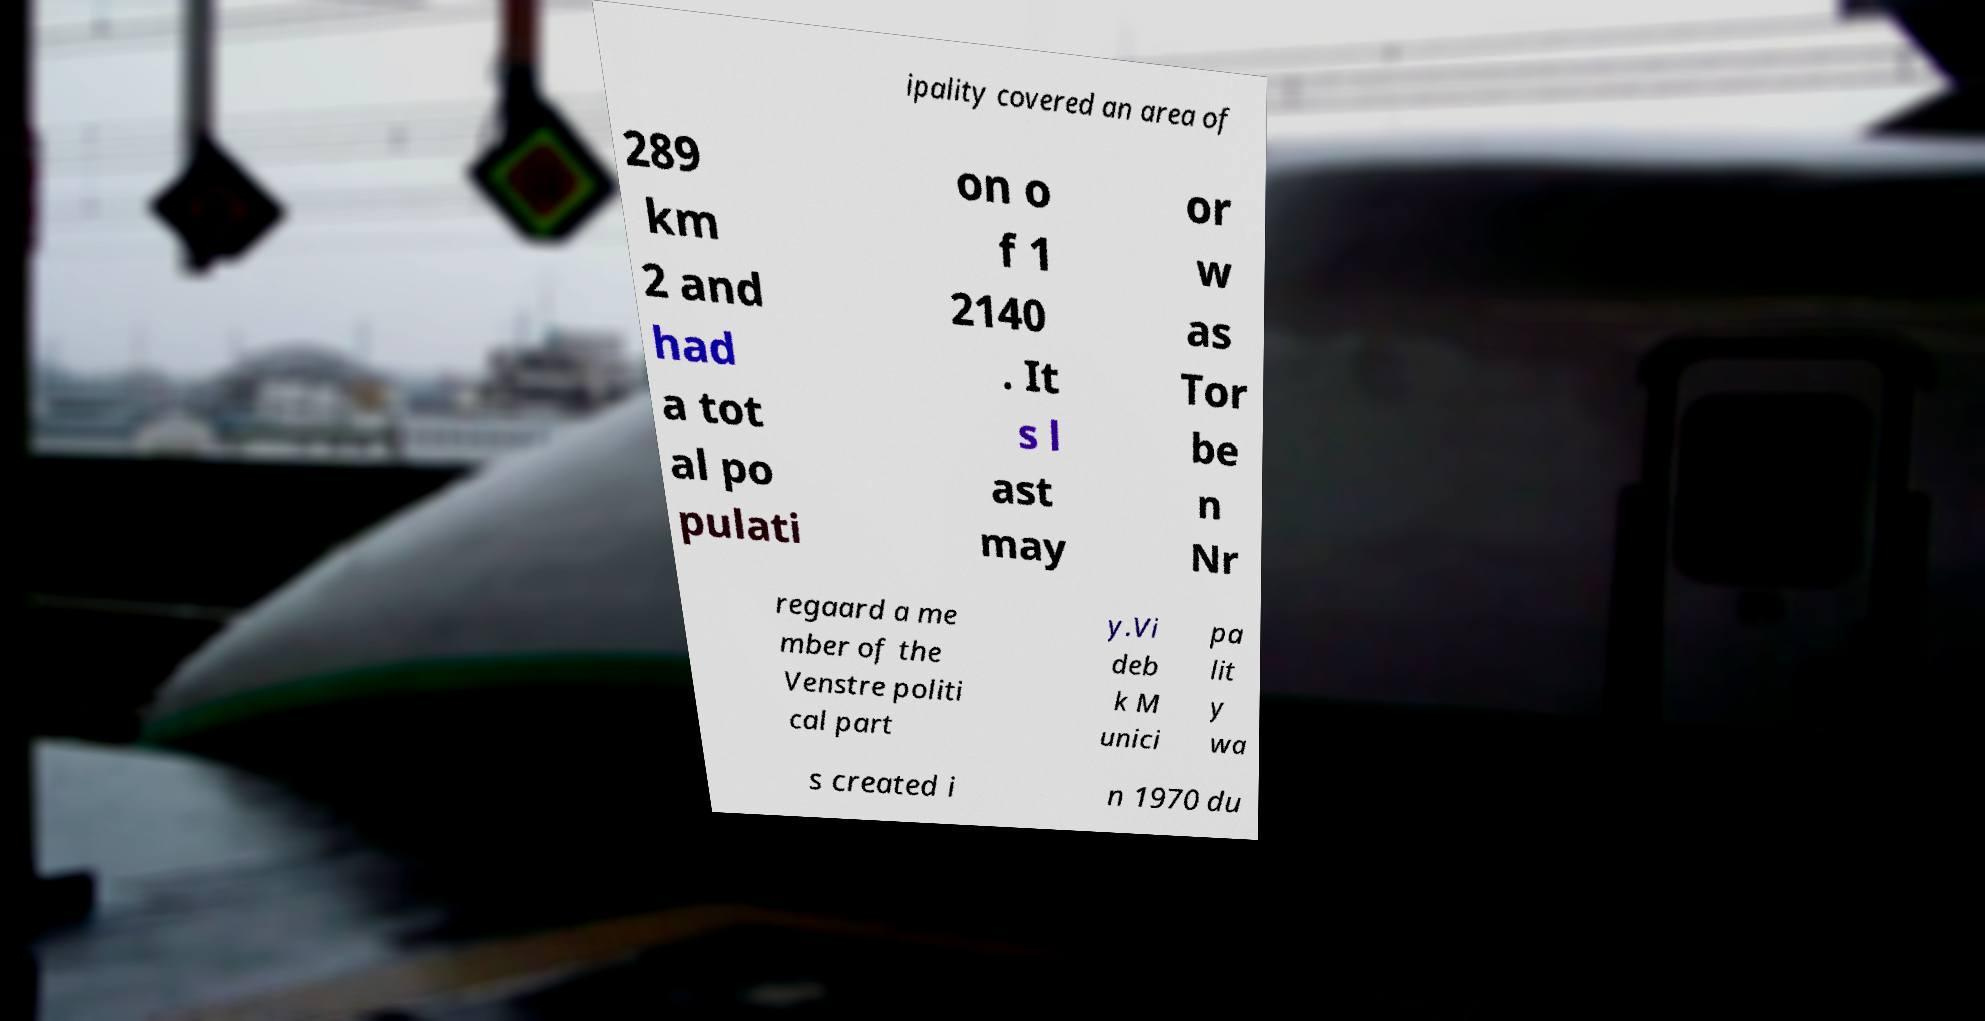Can you accurately transcribe the text from the provided image for me? ipality covered an area of 289 km 2 and had a tot al po pulati on o f 1 2140 . It s l ast may or w as Tor be n Nr regaard a me mber of the Venstre politi cal part y.Vi deb k M unici pa lit y wa s created i n 1970 du 